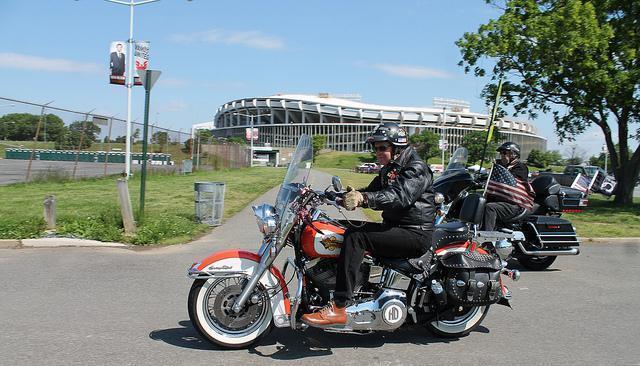What color is the rubber surrounding the outer rim of the tire on these bikes?
Answer the question by selecting the correct answer among the 4 following choices.
Options: Black, blue, white, green. White. 